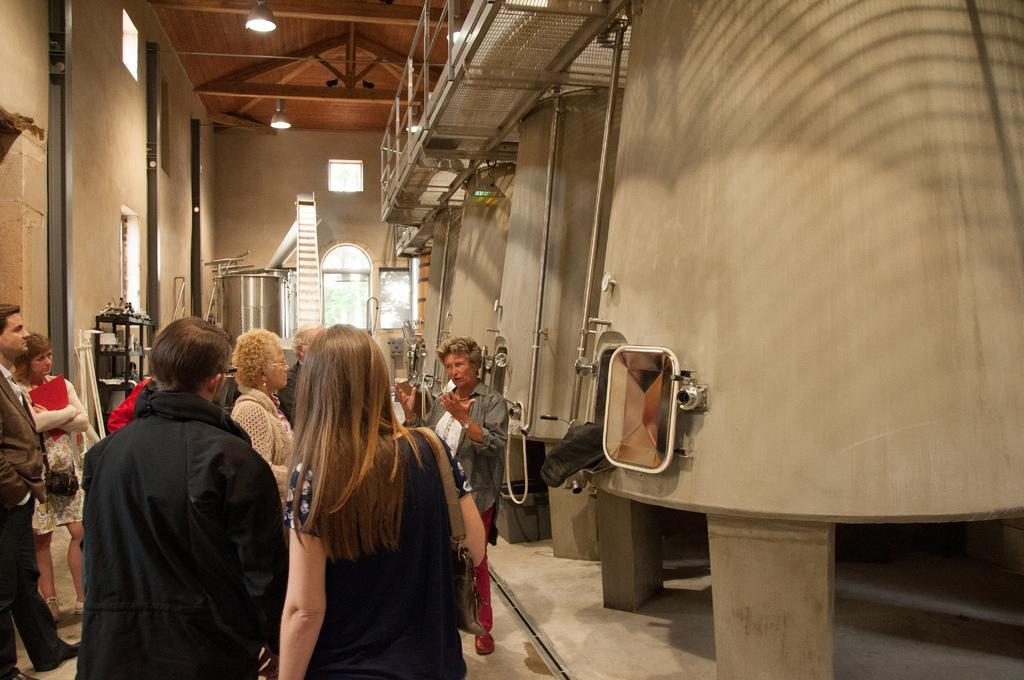What can be seen in the image? There are people standing in the image, along with tanks, a wall, a ladder, and a tank in the background. Can you describe the roof in the image? There is a wooden roof at the top of the image. What else can be seen at the top of the image? There are lights at the top of the image. How much payment is required to access the sail in the image? There is no sail present in the image, so payment is not required for any sail. What type of regret is expressed by the people in the image? There is no indication of regret in the image; the people are simply standing. 